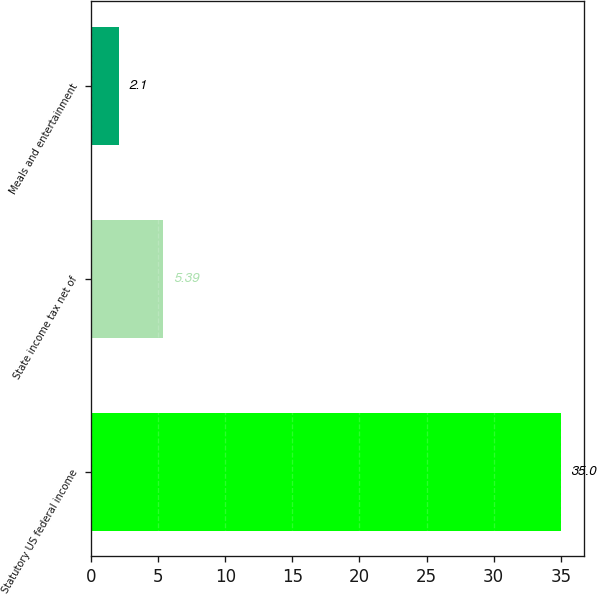Convert chart to OTSL. <chart><loc_0><loc_0><loc_500><loc_500><bar_chart><fcel>Statutory US federal income<fcel>State income tax net of<fcel>Meals and entertainment<nl><fcel>35<fcel>5.39<fcel>2.1<nl></chart> 